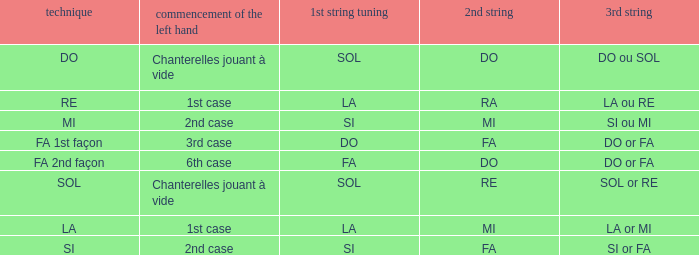For a 1st string of si accord du and a 2nd string of mi, what is the third string? SI ou MI. 